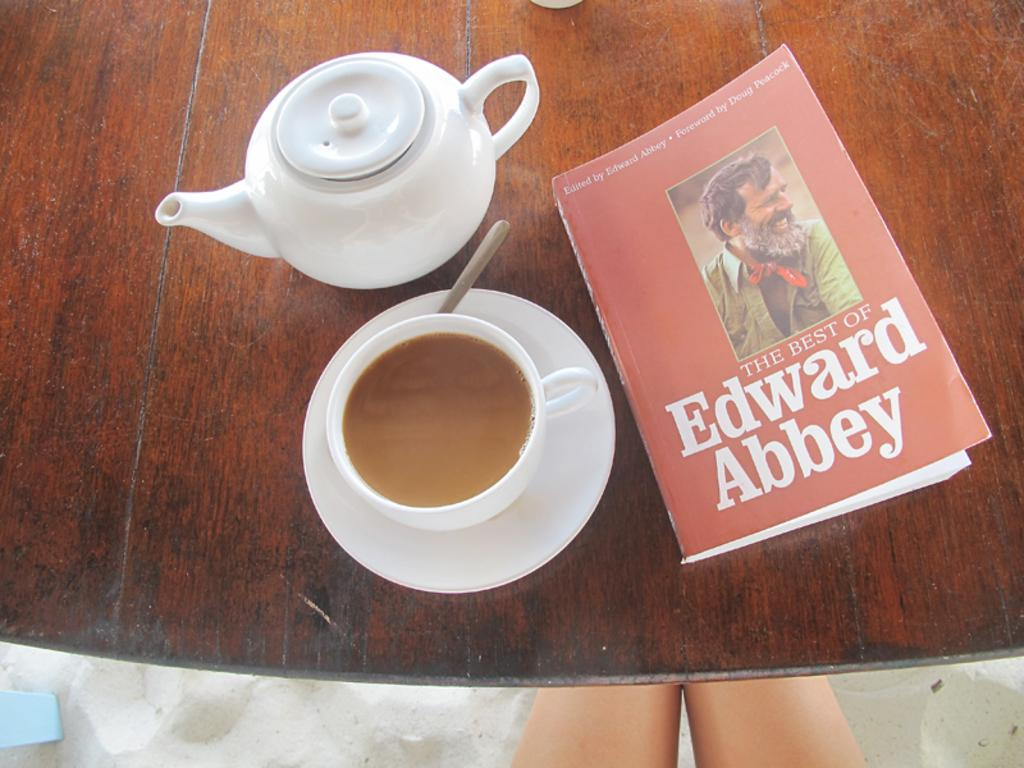Provide a one-sentence caption for the provided image. A tea kettle and a cup of tea are on the table with a book titled "The Best of Edward Abbey.". 